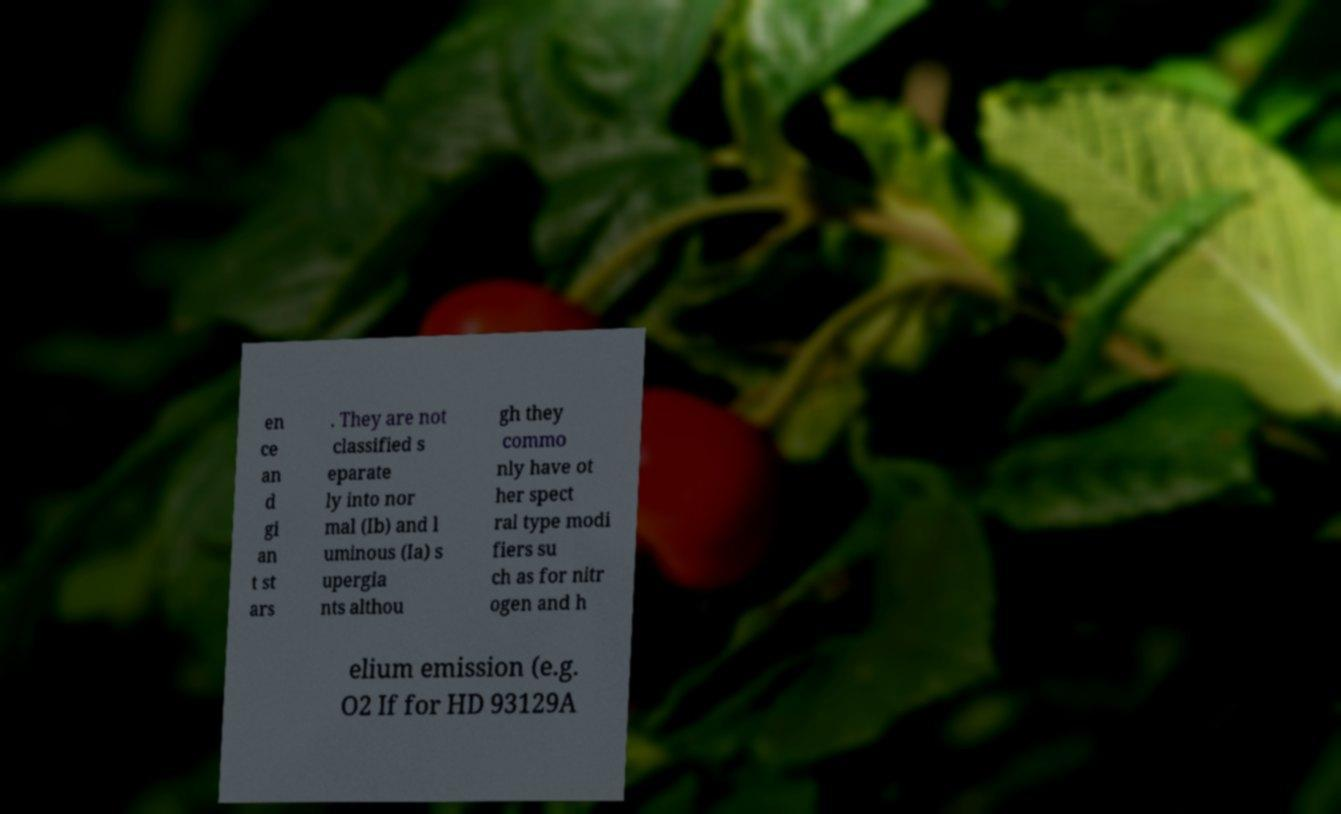For documentation purposes, I need the text within this image transcribed. Could you provide that? en ce an d gi an t st ars . They are not classified s eparate ly into nor mal (Ib) and l uminous (Ia) s upergia nts althou gh they commo nly have ot her spect ral type modi fiers su ch as for nitr ogen and h elium emission (e.g. O2 If for HD 93129A 